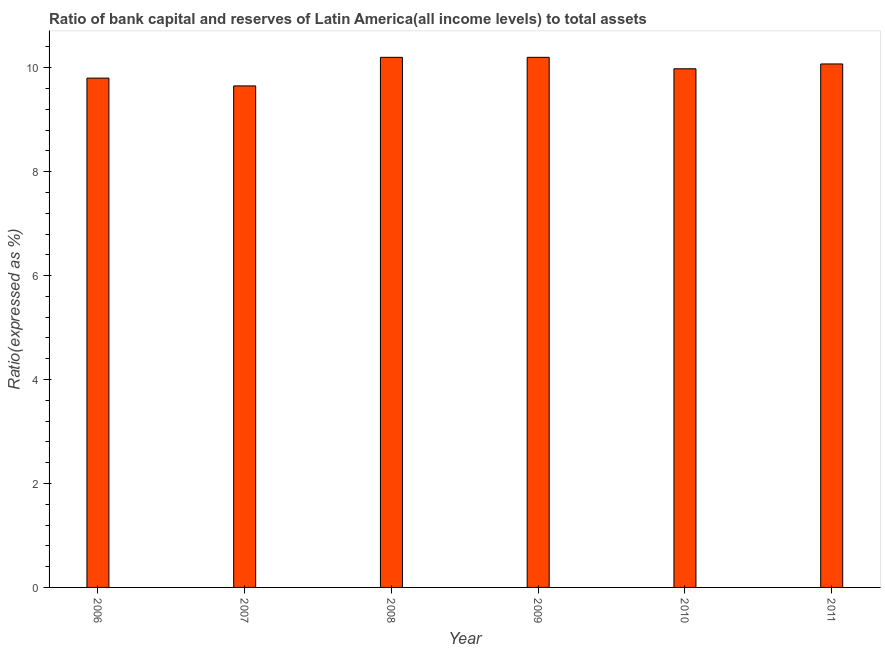Does the graph contain grids?
Your answer should be compact. No. What is the title of the graph?
Offer a very short reply. Ratio of bank capital and reserves of Latin America(all income levels) to total assets. What is the label or title of the X-axis?
Offer a terse response. Year. What is the label or title of the Y-axis?
Give a very brief answer. Ratio(expressed as %). What is the bank capital to assets ratio in 2011?
Your answer should be very brief. 10.07. Across all years, what is the maximum bank capital to assets ratio?
Offer a very short reply. 10.2. Across all years, what is the minimum bank capital to assets ratio?
Provide a succinct answer. 9.65. In which year was the bank capital to assets ratio maximum?
Provide a short and direct response. 2008. In which year was the bank capital to assets ratio minimum?
Provide a short and direct response. 2007. What is the sum of the bank capital to assets ratio?
Make the answer very short. 59.9. What is the difference between the bank capital to assets ratio in 2006 and 2008?
Give a very brief answer. -0.4. What is the average bank capital to assets ratio per year?
Offer a terse response. 9.98. What is the median bank capital to assets ratio?
Your answer should be compact. 10.03. Is the difference between the bank capital to assets ratio in 2006 and 2010 greater than the difference between any two years?
Ensure brevity in your answer.  No. Is the sum of the bank capital to assets ratio in 2006 and 2010 greater than the maximum bank capital to assets ratio across all years?
Provide a succinct answer. Yes. What is the difference between the highest and the lowest bank capital to assets ratio?
Your response must be concise. 0.55. How many bars are there?
Your answer should be compact. 6. How many years are there in the graph?
Offer a terse response. 6. What is the difference between two consecutive major ticks on the Y-axis?
Give a very brief answer. 2. What is the Ratio(expressed as %) in 2007?
Keep it short and to the point. 9.65. What is the Ratio(expressed as %) of 2008?
Make the answer very short. 10.2. What is the Ratio(expressed as %) of 2009?
Your response must be concise. 10.2. What is the Ratio(expressed as %) of 2010?
Your answer should be compact. 9.98. What is the Ratio(expressed as %) in 2011?
Offer a very short reply. 10.07. What is the difference between the Ratio(expressed as %) in 2006 and 2009?
Your answer should be very brief. -0.4. What is the difference between the Ratio(expressed as %) in 2006 and 2010?
Offer a terse response. -0.18. What is the difference between the Ratio(expressed as %) in 2006 and 2011?
Your answer should be very brief. -0.27. What is the difference between the Ratio(expressed as %) in 2007 and 2008?
Provide a succinct answer. -0.55. What is the difference between the Ratio(expressed as %) in 2007 and 2009?
Offer a terse response. -0.55. What is the difference between the Ratio(expressed as %) in 2007 and 2010?
Offer a terse response. -0.33. What is the difference between the Ratio(expressed as %) in 2007 and 2011?
Make the answer very short. -0.42. What is the difference between the Ratio(expressed as %) in 2008 and 2009?
Your answer should be very brief. 0. What is the difference between the Ratio(expressed as %) in 2008 and 2010?
Your answer should be compact. 0.22. What is the difference between the Ratio(expressed as %) in 2008 and 2011?
Your response must be concise. 0.13. What is the difference between the Ratio(expressed as %) in 2009 and 2010?
Offer a very short reply. 0.22. What is the difference between the Ratio(expressed as %) in 2009 and 2011?
Ensure brevity in your answer.  0.13. What is the difference between the Ratio(expressed as %) in 2010 and 2011?
Give a very brief answer. -0.09. What is the ratio of the Ratio(expressed as %) in 2007 to that in 2008?
Offer a terse response. 0.95. What is the ratio of the Ratio(expressed as %) in 2007 to that in 2009?
Offer a terse response. 0.95. What is the ratio of the Ratio(expressed as %) in 2007 to that in 2011?
Your response must be concise. 0.96. What is the ratio of the Ratio(expressed as %) in 2008 to that in 2010?
Make the answer very short. 1.02. What is the ratio of the Ratio(expressed as %) in 2009 to that in 2011?
Your response must be concise. 1.01. 